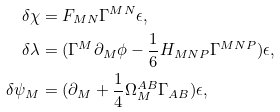Convert formula to latex. <formula><loc_0><loc_0><loc_500><loc_500>\delta \chi & = F _ { M N } \Gamma ^ { M N } \epsilon , \\ \delta \lambda & = ( \Gamma ^ { M } \partial _ { M } \phi - \frac { 1 } { 6 } H _ { M N P } \Gamma ^ { M N P } ) \epsilon , \\ \delta \psi _ { M } & = ( \partial _ { M } + \frac { 1 } { 4 } \Omega _ { M } ^ { A B } \Gamma _ { A B } ) \epsilon ,</formula> 